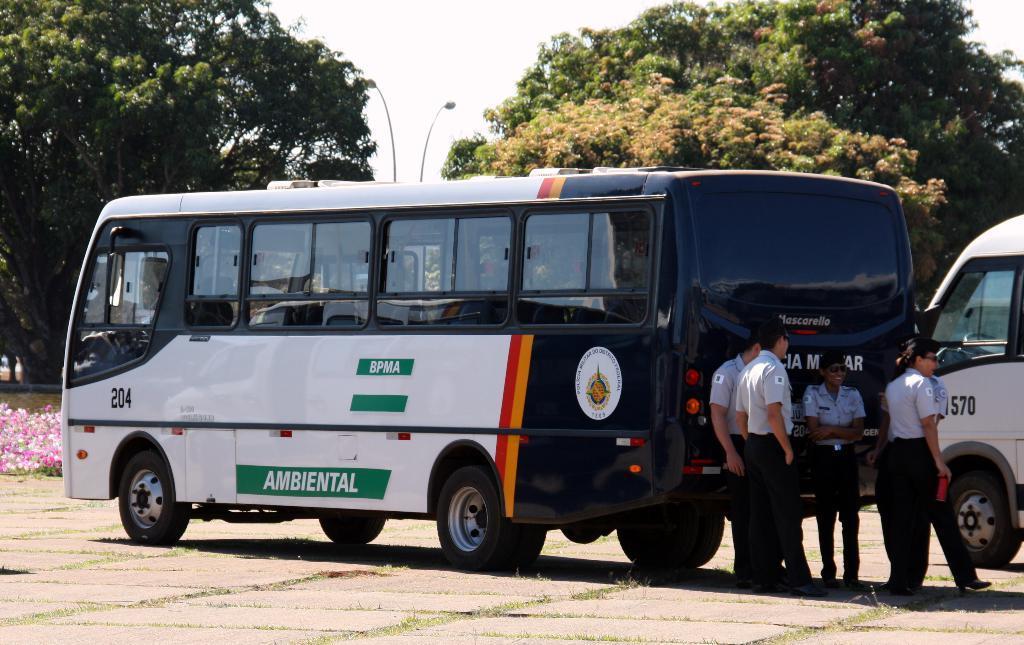Please provide a concise description of this image. In this image there is a bus in the middle and there are few people standing behind the bus. In the background there are trees. In the middle there are street lights. On the left side there are pink flowers on the ground. On the right side there is a van beside the bus. 